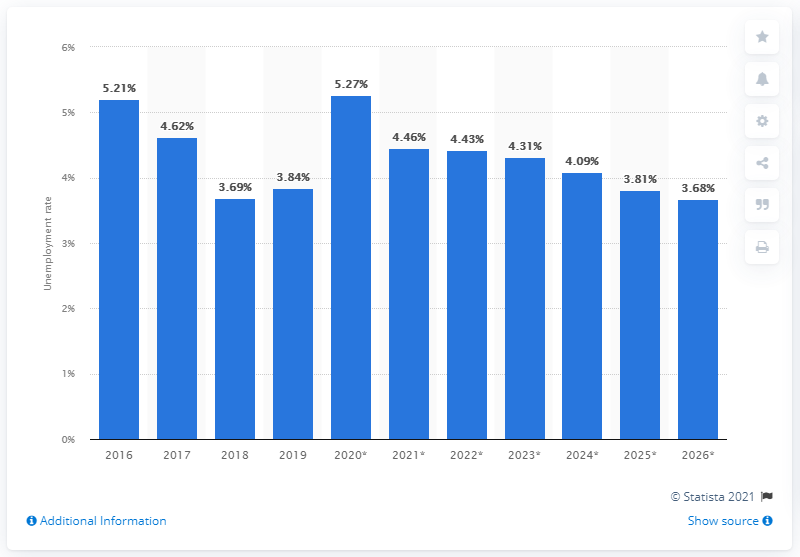Identify some key points in this picture. In 2019, the unemployment rate in Ecuador was 3.81%. 